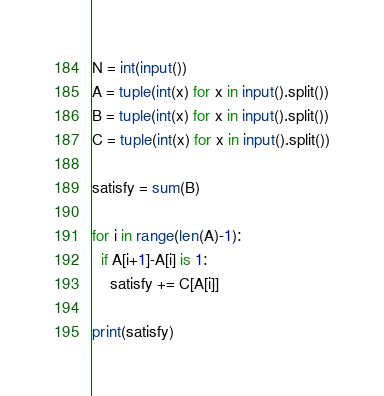Convert code to text. <code><loc_0><loc_0><loc_500><loc_500><_Python_>N = int(input())
A = tuple(int(x) for x in input().split())
B = tuple(int(x) for x in input().split())
C = tuple(int(x) for x in input().split())

satisfy = sum(B)

for i in range(len(A)-1):
  if A[i+1]-A[i] is 1:
    satisfy += C[A[i]]

print(satisfy)</code> 